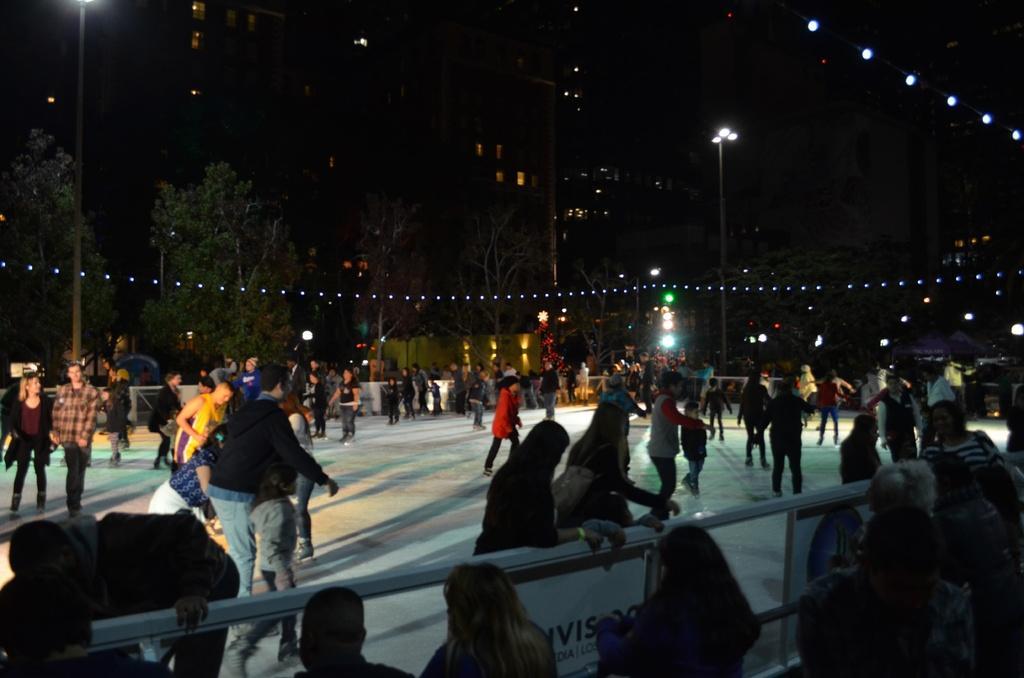How would you summarize this image in a sentence or two? In the center of the image we can see people doing ice skating and there is crowd. We can see fence. In the background there are trees, poles, buildings and lights. 